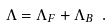Convert formula to latex. <formula><loc_0><loc_0><loc_500><loc_500>\Lambda = \Lambda _ { F } + \Lambda _ { B } \ .</formula> 